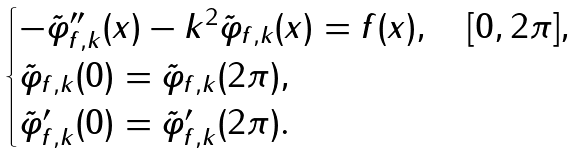Convert formula to latex. <formula><loc_0><loc_0><loc_500><loc_500>\begin{cases} - \tilde { \varphi } _ { f , k } ^ { \prime \prime } ( x ) - k ^ { 2 } \tilde { \varphi } _ { f , k } ( x ) = f ( x ) , \quad [ 0 , 2 \pi ] , \\ \tilde { \varphi } _ { f , k } ( 0 ) = \tilde { \varphi } _ { f , k } ( 2 \pi ) , \\ \tilde { \varphi } _ { f , k } ^ { \prime } ( 0 ) = \tilde { \varphi } _ { f , k } ^ { \prime } ( 2 \pi ) . \end{cases}</formula> 